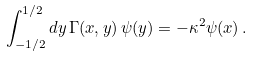Convert formula to latex. <formula><loc_0><loc_0><loc_500><loc_500>\int _ { - 1 / 2 } ^ { 1 / 2 } d y \, \Gamma ( x , y ) \, \psi ( y ) = - \kappa ^ { 2 } \psi ( x ) \, .</formula> 